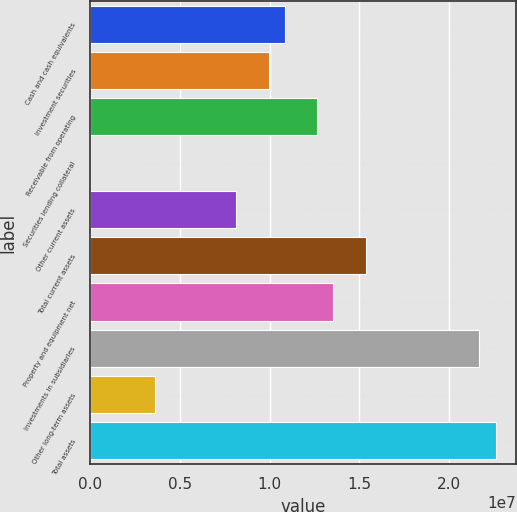Convert chart to OTSL. <chart><loc_0><loc_0><loc_500><loc_500><bar_chart><fcel>Cash and cash equivalents<fcel>Investment securities<fcel>Receivable from operating<fcel>Securities lending collateral<fcel>Other current assets<fcel>Total current assets<fcel>Property and equipment net<fcel>Investments in subsidiaries<fcel>Other long-term assets<fcel>Total assets<nl><fcel>1.08536e+07<fcel>9.94925e+06<fcel>1.26624e+07<fcel>961<fcel>8.14047e+06<fcel>1.53756e+07<fcel>1.35668e+07<fcel>2.17063e+07<fcel>3.61852e+06<fcel>2.26107e+07<nl></chart> 